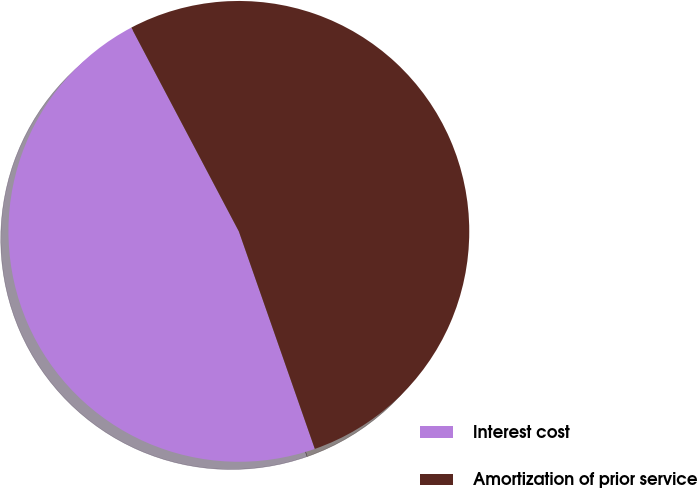Convert chart to OTSL. <chart><loc_0><loc_0><loc_500><loc_500><pie_chart><fcel>Interest cost<fcel>Amortization of prior service<nl><fcel>47.62%<fcel>52.38%<nl></chart> 